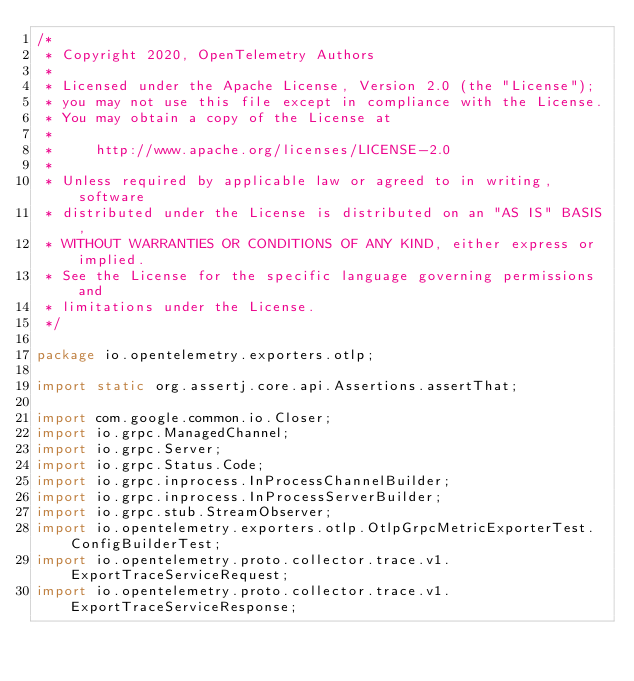Convert code to text. <code><loc_0><loc_0><loc_500><loc_500><_Java_>/*
 * Copyright 2020, OpenTelemetry Authors
 *
 * Licensed under the Apache License, Version 2.0 (the "License");
 * you may not use this file except in compliance with the License.
 * You may obtain a copy of the License at
 *
 *     http://www.apache.org/licenses/LICENSE-2.0
 *
 * Unless required by applicable law or agreed to in writing, software
 * distributed under the License is distributed on an "AS IS" BASIS,
 * WITHOUT WARRANTIES OR CONDITIONS OF ANY KIND, either express or implied.
 * See the License for the specific language governing permissions and
 * limitations under the License.
 */

package io.opentelemetry.exporters.otlp;

import static org.assertj.core.api.Assertions.assertThat;

import com.google.common.io.Closer;
import io.grpc.ManagedChannel;
import io.grpc.Server;
import io.grpc.Status.Code;
import io.grpc.inprocess.InProcessChannelBuilder;
import io.grpc.inprocess.InProcessServerBuilder;
import io.grpc.stub.StreamObserver;
import io.opentelemetry.exporters.otlp.OtlpGrpcMetricExporterTest.ConfigBuilderTest;
import io.opentelemetry.proto.collector.trace.v1.ExportTraceServiceRequest;
import io.opentelemetry.proto.collector.trace.v1.ExportTraceServiceResponse;</code> 